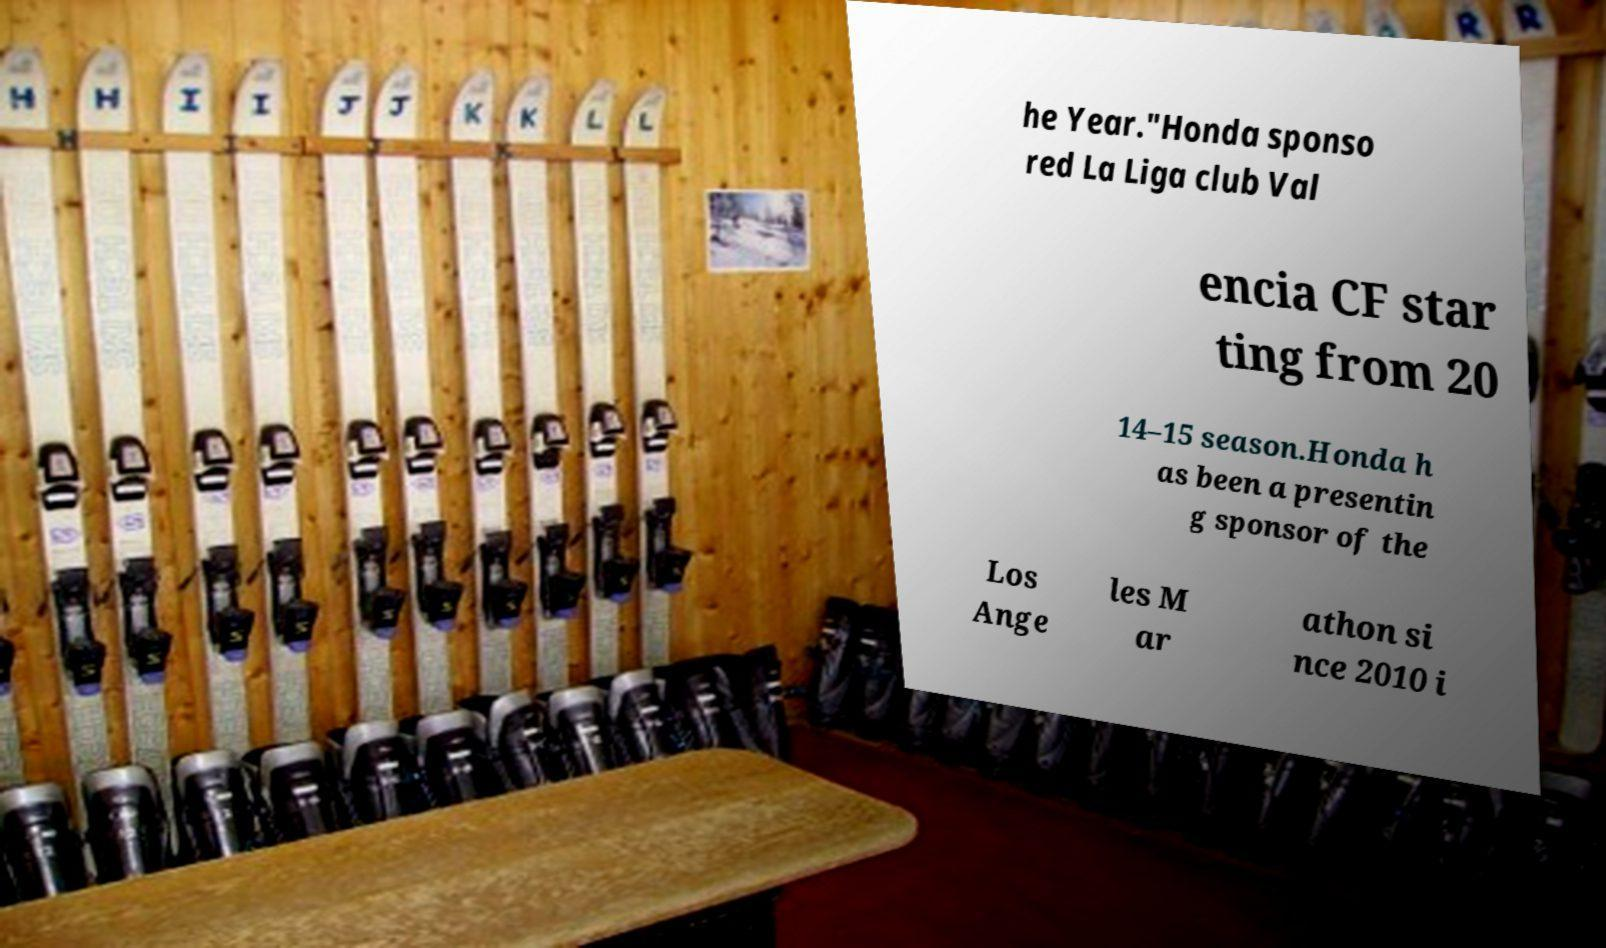Please identify and transcribe the text found in this image. he Year."Honda sponso red La Liga club Val encia CF star ting from 20 14–15 season.Honda h as been a presentin g sponsor of the Los Ange les M ar athon si nce 2010 i 